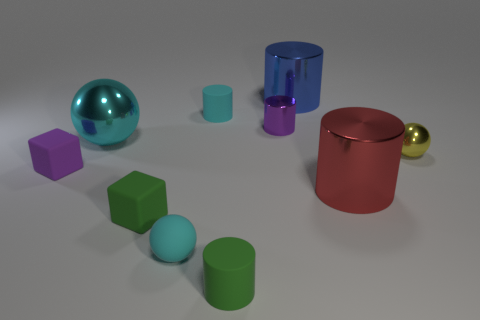Subtract all gray cylinders. Subtract all blue spheres. How many cylinders are left? 5 Subtract all balls. How many objects are left? 7 Add 9 cyan metallic objects. How many cyan metallic objects exist? 10 Subtract 0 yellow cylinders. How many objects are left? 10 Subtract all big cyan balls. Subtract all green matte objects. How many objects are left? 7 Add 6 shiny cylinders. How many shiny cylinders are left? 9 